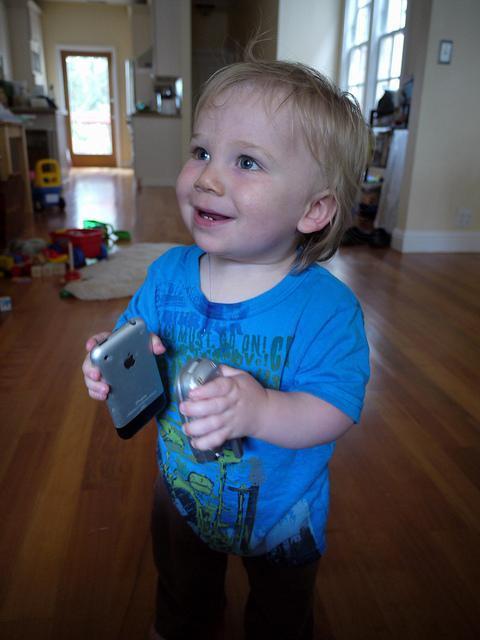How many horses are pictured?
Give a very brief answer. 0. 